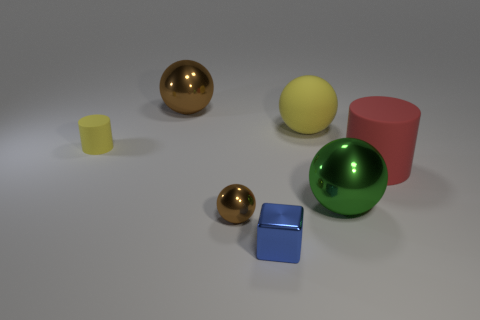Subtract all large brown metal balls. How many balls are left? 3 Subtract all gray spheres. Subtract all purple cubes. How many spheres are left? 4 Add 2 tiny spheres. How many objects exist? 9 Subtract all cubes. How many objects are left? 6 Subtract 0 gray spheres. How many objects are left? 7 Subtract all large purple cylinders. Subtract all green metal balls. How many objects are left? 6 Add 1 big brown objects. How many big brown objects are left? 2 Add 5 tiny rubber cylinders. How many tiny rubber cylinders exist? 6 